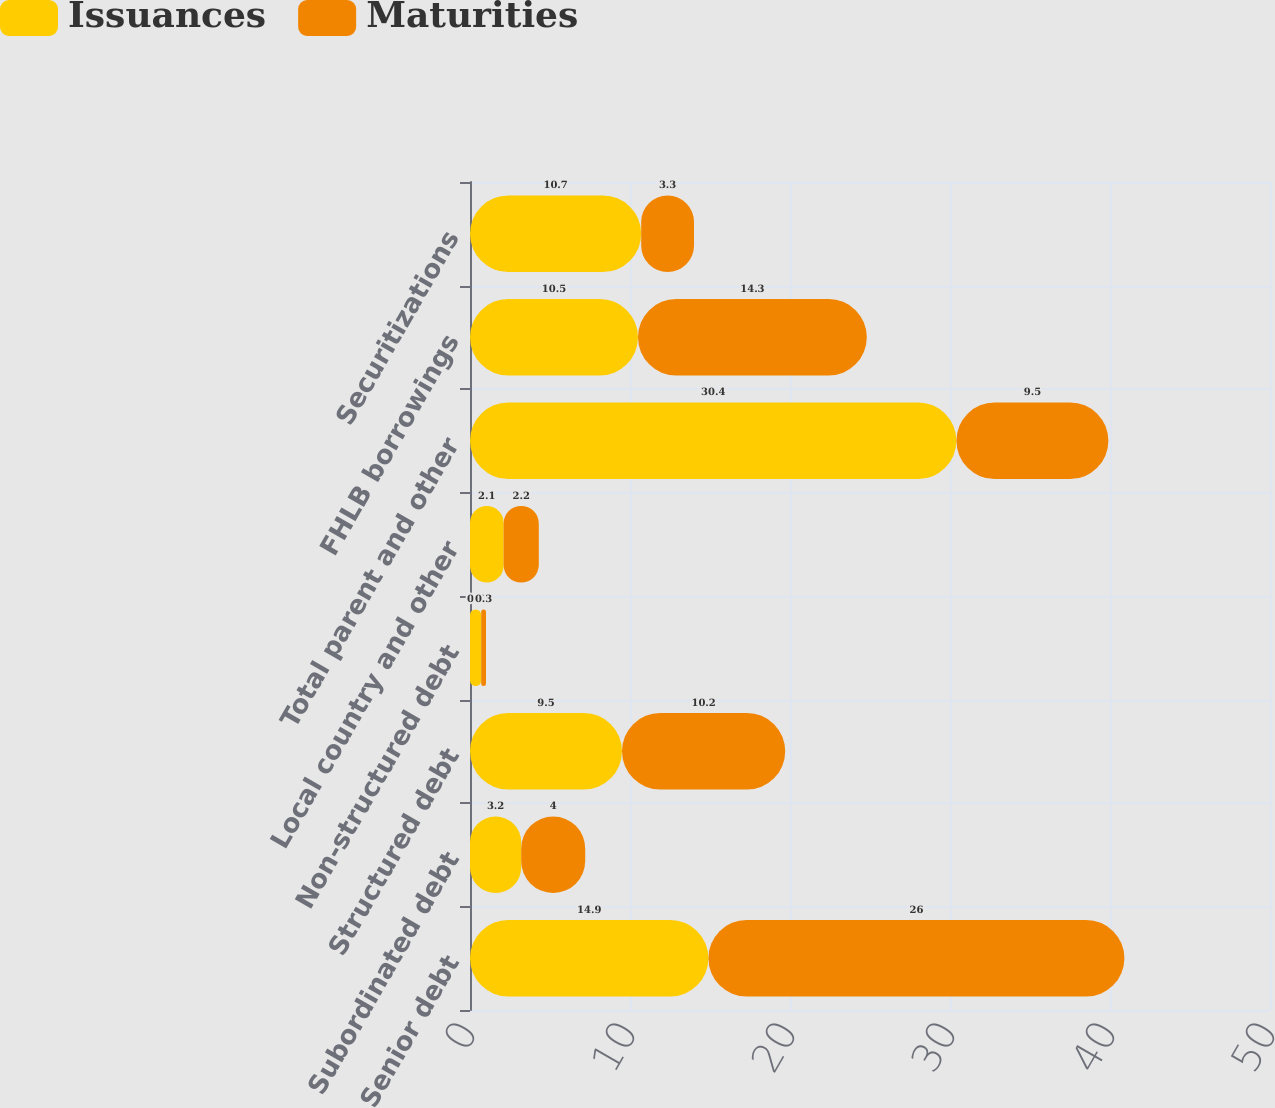<chart> <loc_0><loc_0><loc_500><loc_500><stacked_bar_chart><ecel><fcel>Senior debt<fcel>Subordinated debt<fcel>Structured debt<fcel>Non-structured debt<fcel>Local country and other<fcel>Total parent and other<fcel>FHLB borrowings<fcel>Securitizations<nl><fcel>Issuances<fcel>14.9<fcel>3.2<fcel>9.5<fcel>0.7<fcel>2.1<fcel>30.4<fcel>10.5<fcel>10.7<nl><fcel>Maturities<fcel>26<fcel>4<fcel>10.2<fcel>0.3<fcel>2.2<fcel>9.5<fcel>14.3<fcel>3.3<nl></chart> 